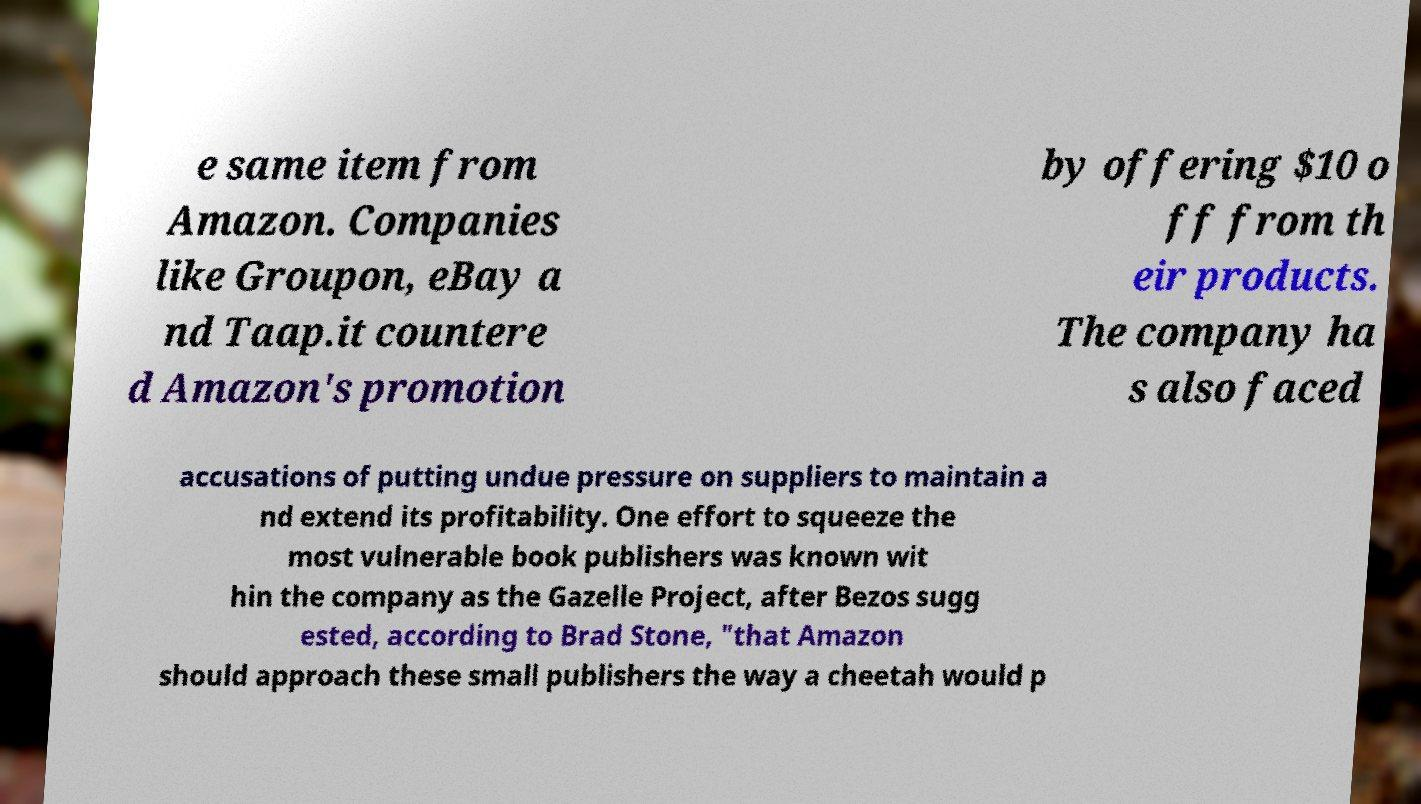For documentation purposes, I need the text within this image transcribed. Could you provide that? e same item from Amazon. Companies like Groupon, eBay a nd Taap.it countere d Amazon's promotion by offering $10 o ff from th eir products. The company ha s also faced accusations of putting undue pressure on suppliers to maintain a nd extend its profitability. One effort to squeeze the most vulnerable book publishers was known wit hin the company as the Gazelle Project, after Bezos sugg ested, according to Brad Stone, "that Amazon should approach these small publishers the way a cheetah would p 